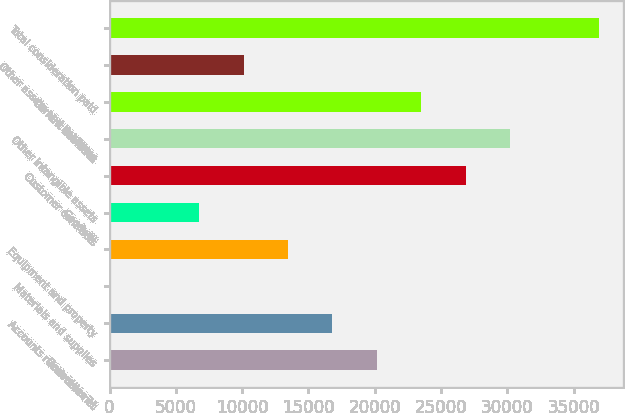Convert chart. <chart><loc_0><loc_0><loc_500><loc_500><bar_chart><fcel>December 31<fcel>Accounts receivable net<fcel>Materials and supplies<fcel>Equipment and property<fcel>Goodwill<fcel>Customer contracts<fcel>Other intangible assets<fcel>Current liabilities<fcel>Other assets and liabilities<fcel>Total consideration paid<nl><fcel>20156.6<fcel>16809<fcel>71<fcel>13461.4<fcel>6766.2<fcel>26851.8<fcel>30199.4<fcel>23504.2<fcel>10113.8<fcel>36894.6<nl></chart> 